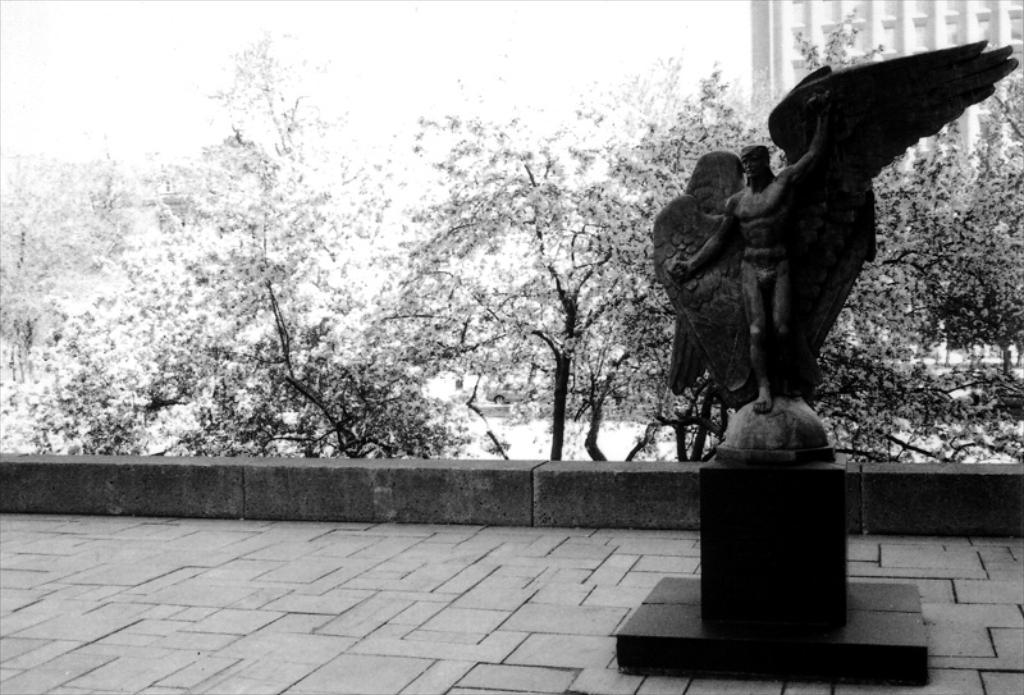What can be seen in the sky in the image? There is a sky visible in the image. What type of natural vegetation is present in the image? There are trees in the image. What type of man-made structure is present in the image? There is a building in the image. What type of artistic object is present in the image? There is a statue in the image. What type of root can be seen growing from the statue in the image? There is no root growing from the statue in the image; it is a standalone statue. How does the statue express anger in the image? The statue does not express anger in the image; it is a stationary object. 